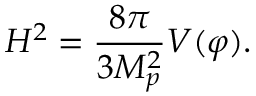<formula> <loc_0><loc_0><loc_500><loc_500>H ^ { 2 } = \frac { 8 \pi } { 3 M _ { p } ^ { 2 } } V ( \varphi ) .</formula> 